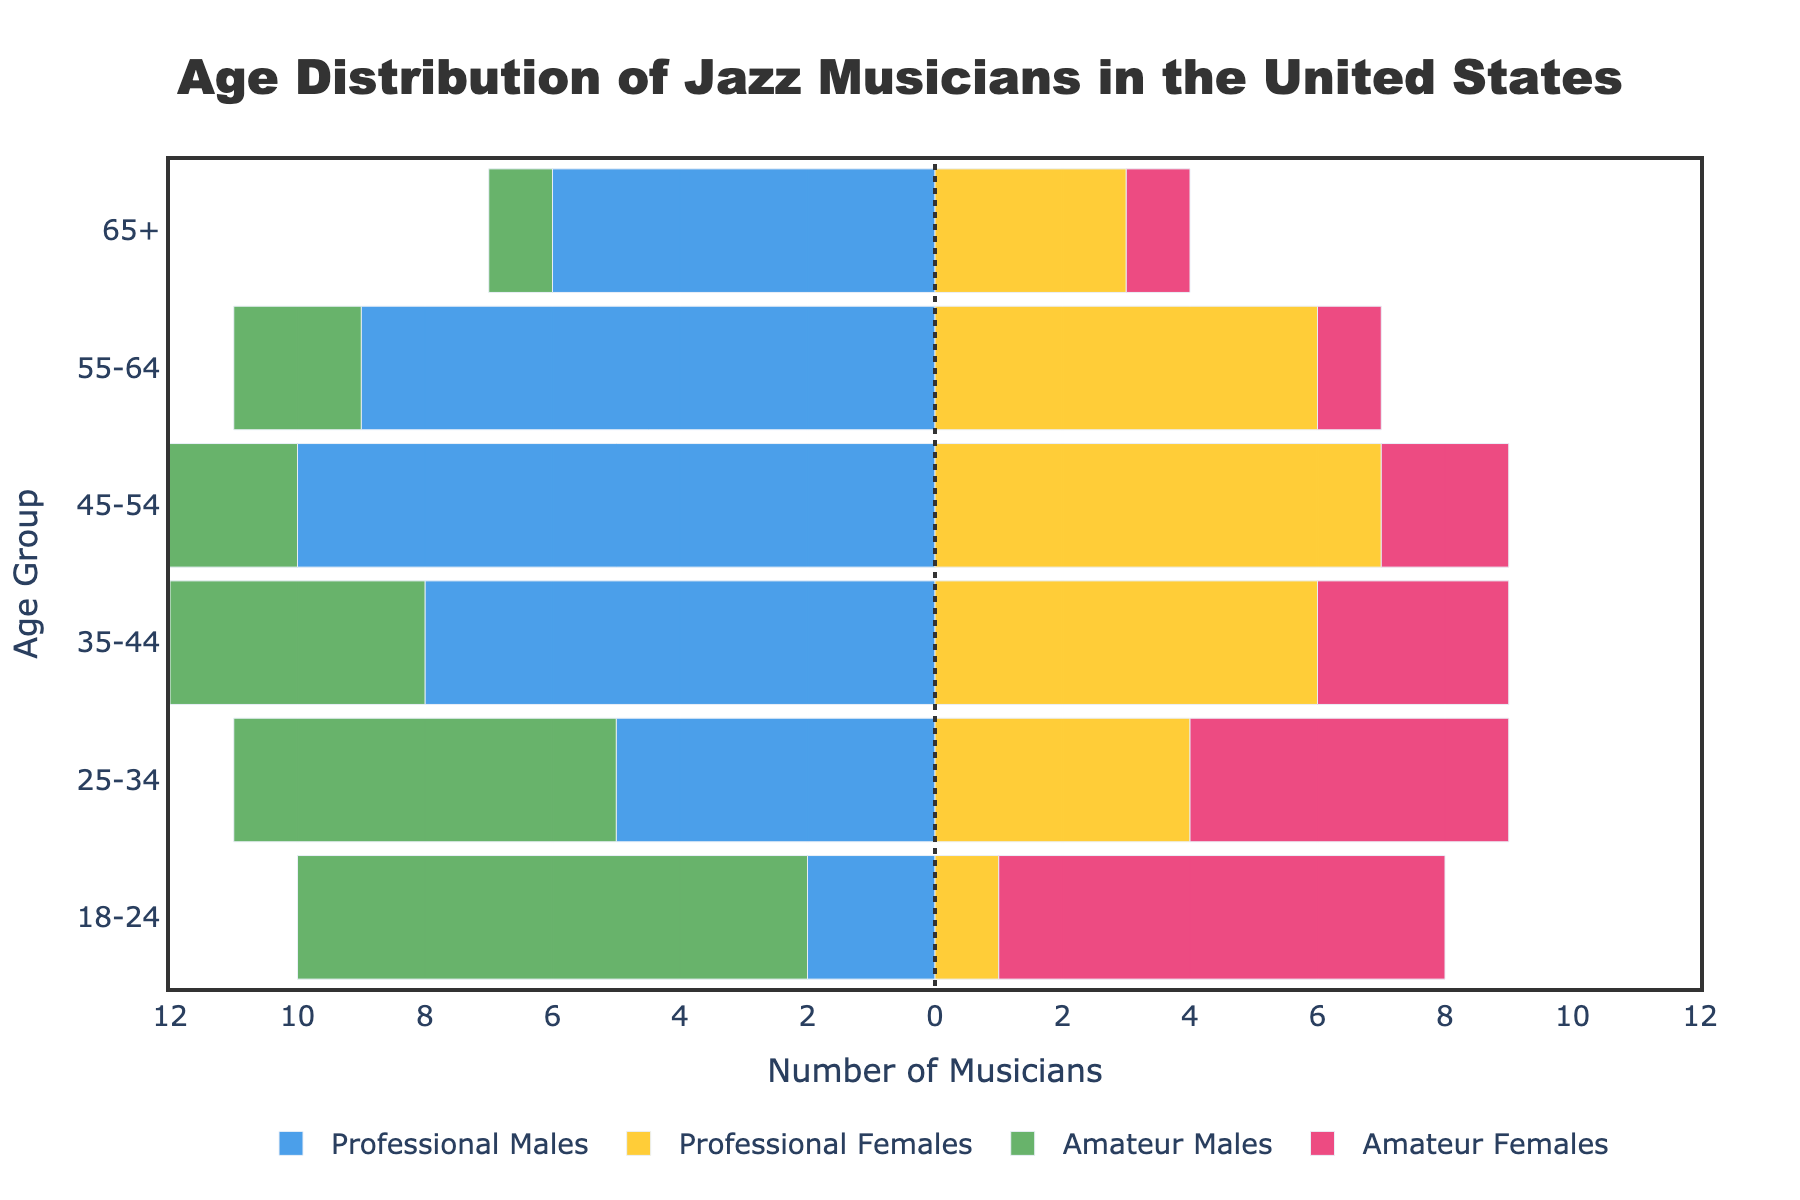What is the title of the figure? The title can be found at the top of the chart, which states the descriptive overall context of the pyramid.
Answer: Age Distribution of Jazz Musicians in the United States Which age group has the highest number of professional male musicians? By examining the longest bar extending to the left for professional males, the 45-54 age group has the highest count.
Answer: 45-54 How many amateur female musicians are there in the 18-24 age group? Look at the height of the bar for amateur females corresponding to the 18-24 age group.
Answer: 7 What is the total number of professional musicians in the 55-64 age group? Add the number of professional males and professional females for the 55-64 age group: 9 (males) + 6 (females) = 15
Answer: 15 Compare the number of amateur and professional male musicians in the 25-34 age group. Who are more? Observe the lengths of the bars extending to the left for amateur and professional males in the 25-34 age group. There are 6 amateur males and 5 professional males.
Answer: More amateur males What is the difference in number between professional and amateur female musicians in the 35-44 age group? Subtract the number of amateur females from professional females in the 35-44 age group: 6 (professionals) - 3 (amateurs) = 3
Answer: 3 Which group has fewer musicians, professional females or amateur males, in the 65+ age group? Compare the bar lengths for professional females and amateur males in the 65+ age group: 3 professional females versus 1 amateur male.
Answer: Amateur Males What is the overall trend in the number of professional male musicians as age increases? Examine the lengths of the bars for professional males across the age groups. The number generally increases until 45-54, then starts to decrease.
Answer: Increase then decrease How many more amateur male musicians are there compared to professional male musicians in the 18-24 age group? Subtract the number of professional males from amateur males in the 18-24 age group: 8 (amateurs) - 2 (professionals) = 6
Answer: 6 Which age group has the most balanced distribution of musicians across all categories? Assess the age group where all bars (professional males, professional females, amateur males, amateur females) are nearly equal in length. The 25-34 age group shows a relatively balanced distribution.
Answer: 25-34 